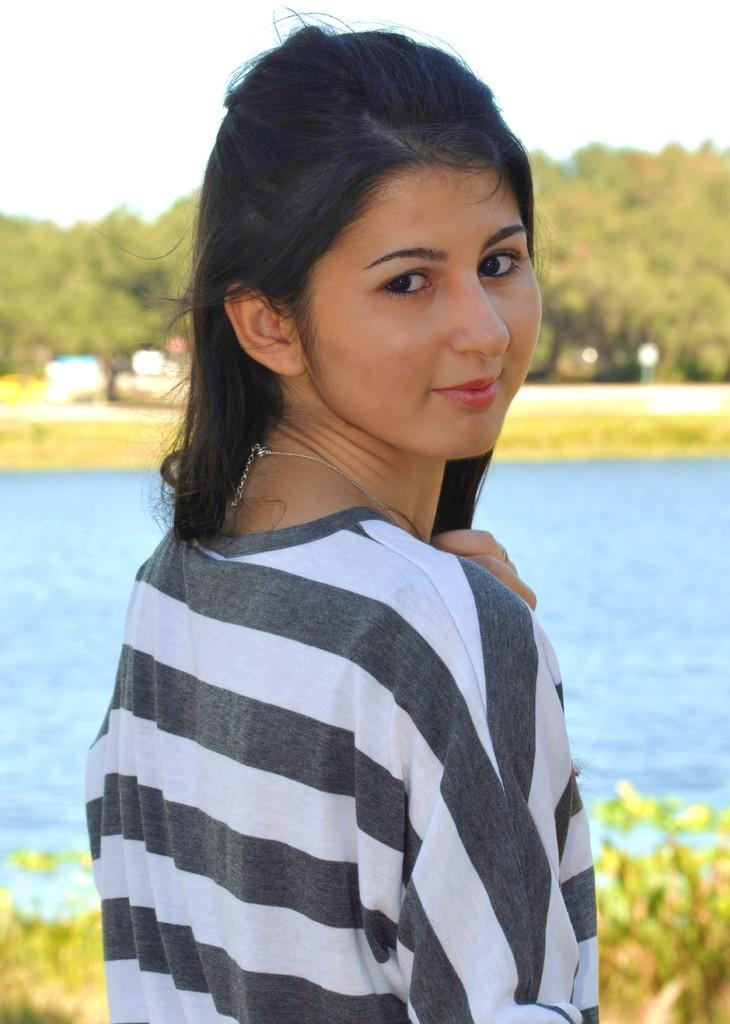Who is present in the image? There is a woman in the image. What is the woman's expression? The woman is smiling. What type of vegetation can be seen in the image? There are plants and trees visible in the image. What can be seen in the background of the image? There is water, trees, and the sky visible in the background of the image. What type of boot is the woman wearing in the image? The image does not show the woman wearing any boots, so it is not possible to determine the type of boot she might be wearing. 